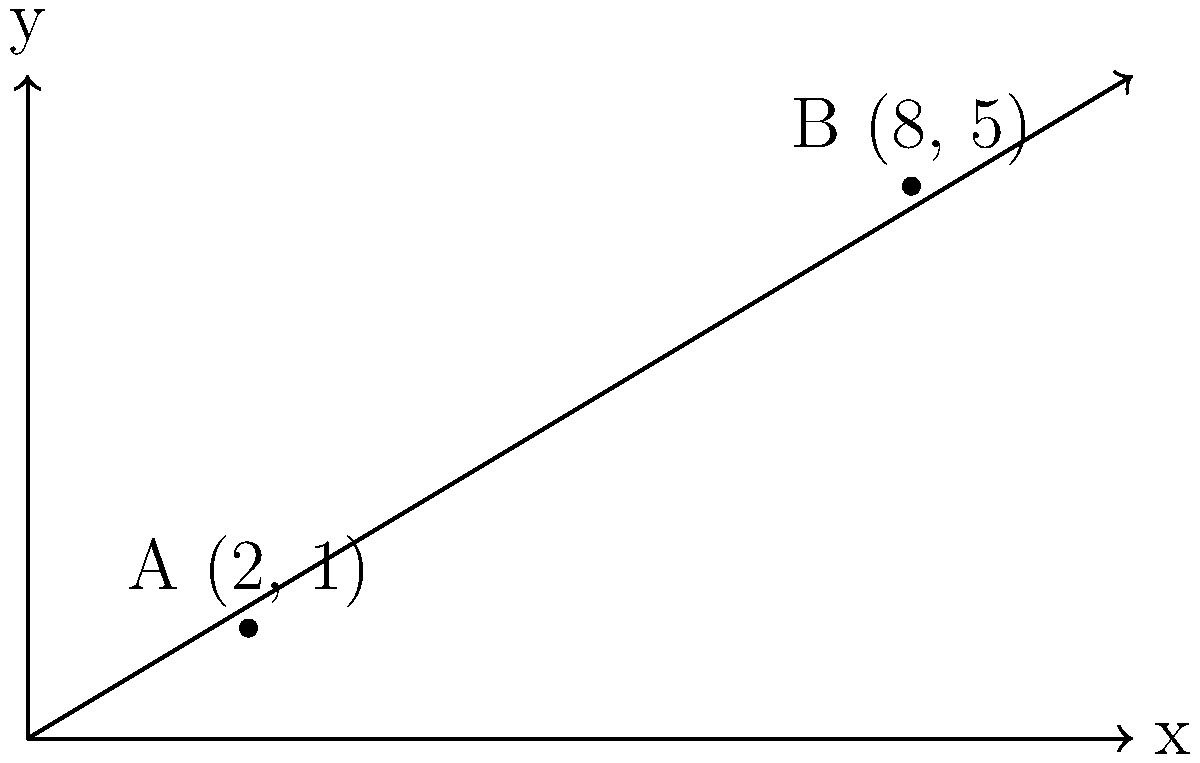During a covert operation in World War II, you've identified two enemy strongholds at coordinates A(2, 1) and B(8, 5). To plan an effective strategy, you need to determine the equation of the line passing through these two points. What is the equation of this line in slope-intercept form $(y = mx + b)$? To find the equation of the line passing through two points, we can follow these steps:

1. Calculate the slope $(m)$ using the slope formula:
   $m = \frac{y_2 - y_1}{x_2 - x_1} = \frac{5 - 1}{8 - 2} = \frac{4}{6} = \frac{2}{3}$

2. Use the point-slope form of a line $(y - y_1 = m(x - x_1))$ with either point. Let's use A(2, 1):
   $y - 1 = \frac{2}{3}(x - 2)$

3. Expand the equation:
   $y - 1 = \frac{2}{3}x - \frac{4}{3}$

4. Solve for $y$ to get the slope-intercept form $(y = mx + b)$:
   $y = \frac{2}{3}x - \frac{4}{3} + 1$
   $y = \frac{2}{3}x - \frac{1}{3}$

Therefore, the equation of the line passing through the two enemy strongholds is $y = \frac{2}{3}x - \frac{1}{3}$.
Answer: $y = \frac{2}{3}x - \frac{1}{3}$ 